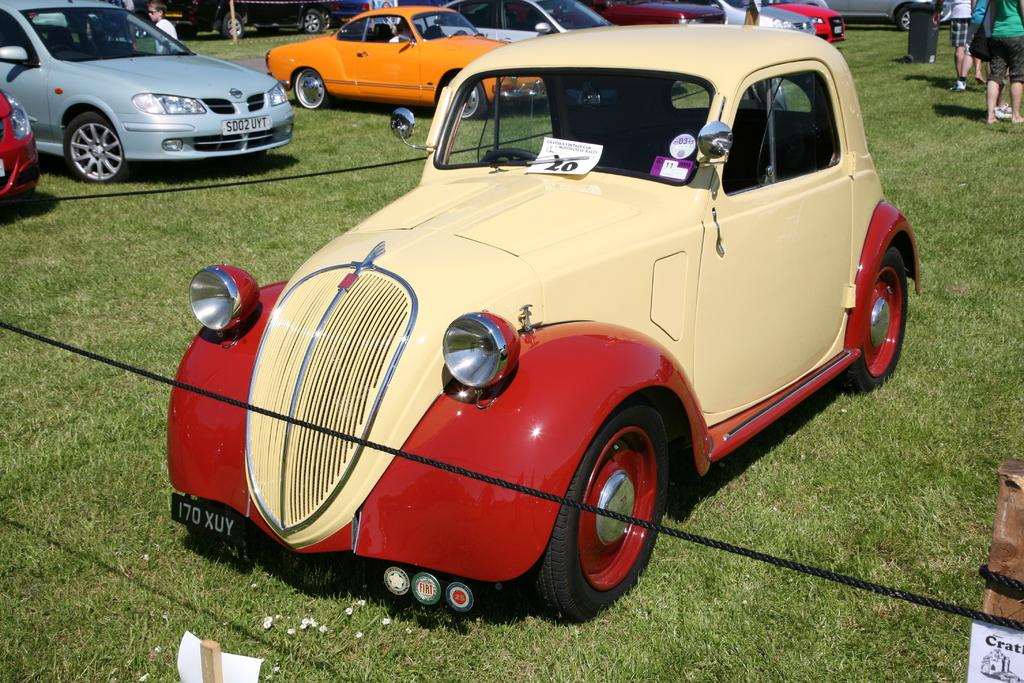What type of surface do the vehicles appear to be on in the image? The vehicles are on the grass in the image. What objects can be seen in the image that are used for tying or securing? There are ropes in the image. What type of signage is present in the image? There are posters in the image. What objects can be seen in the image that are used for support or construction? There are sticks in the image. What type of container is present in the image for waste disposal? There is a bin in the image. Can you identify any individuals in the image? Yes, there is a person in the image, and there are people visible in the top right corner of the image. What type of cake is being served by the manager in the image? There is no cake or manager present in the image. How does the person in the image take a bath while standing on the grass? The person in the image is not taking a bath, and there is no indication of a bath or water in the image. 